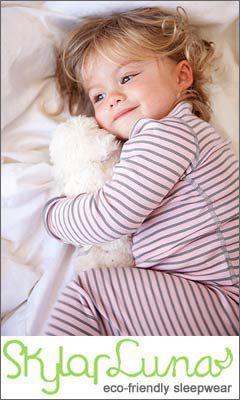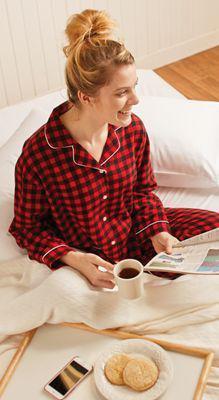The first image is the image on the left, the second image is the image on the right. For the images displayed, is the sentence "In one of the pictures, there is a smiling child with a stuffed animal near it, and in the other picture there is a woman alone." factually correct? Answer yes or no. Yes. The first image is the image on the left, the second image is the image on the right. Assess this claim about the two images: "An image shows a child in sleepwear near a stuffed animal, with no adult present.". Correct or not? Answer yes or no. Yes. 